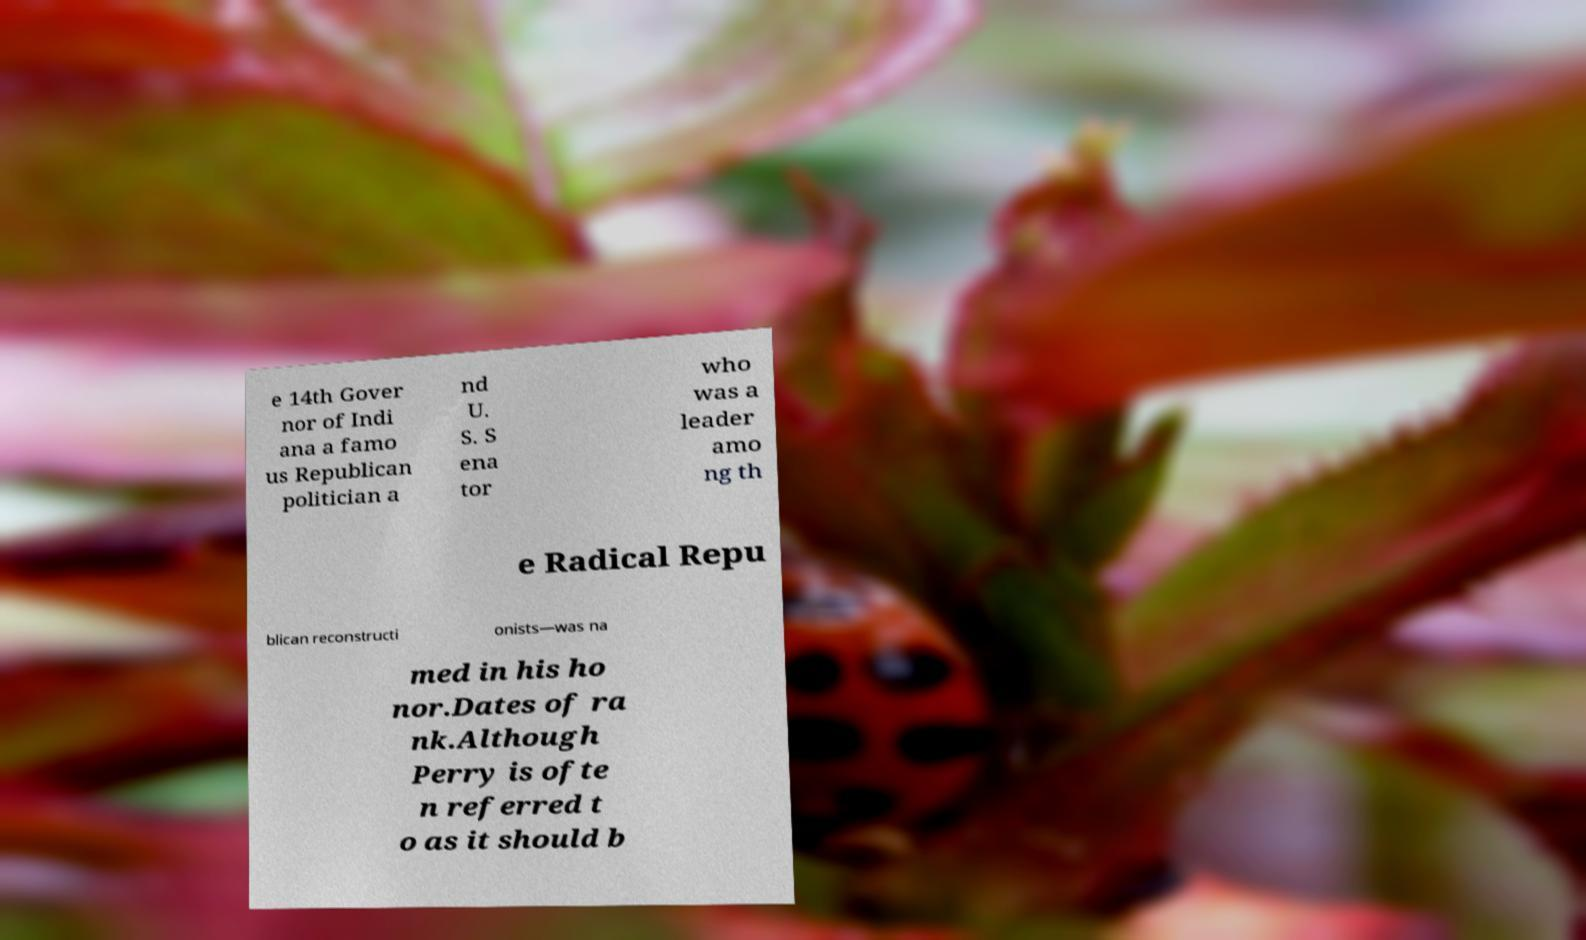Please read and relay the text visible in this image. What does it say? e 14th Gover nor of Indi ana a famo us Republican politician a nd U. S. S ena tor who was a leader amo ng th e Radical Repu blican reconstructi onists—was na med in his ho nor.Dates of ra nk.Although Perry is ofte n referred t o as it should b 